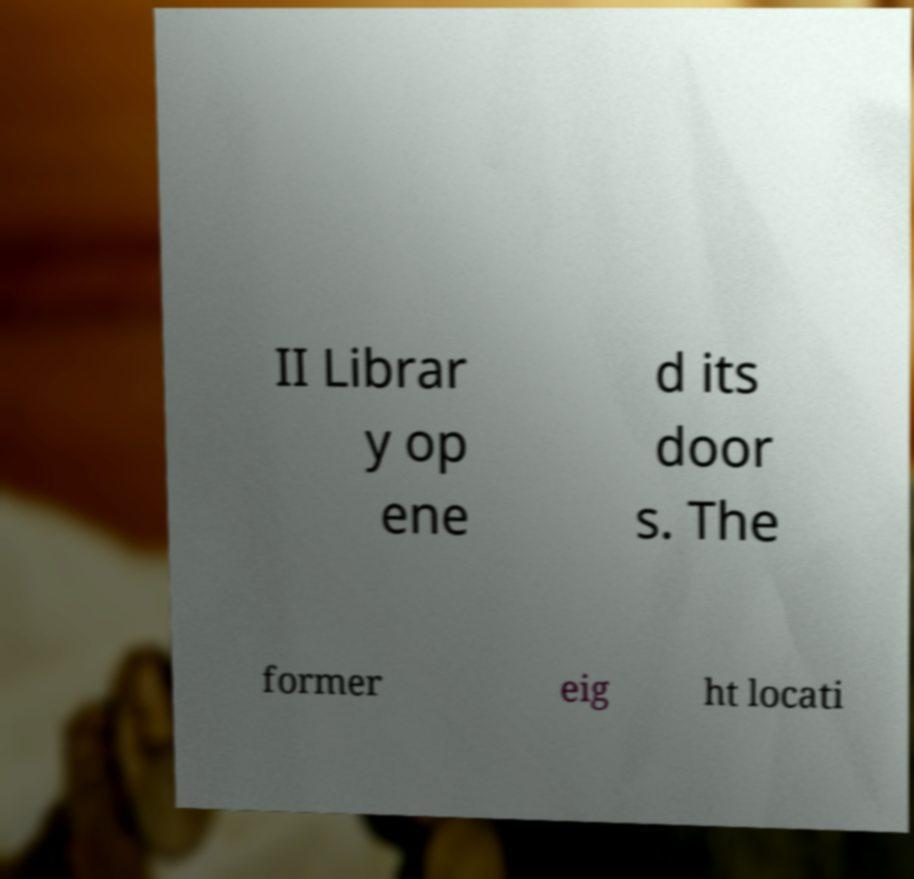For documentation purposes, I need the text within this image transcribed. Could you provide that? II Librar y op ene d its door s. The former eig ht locati 